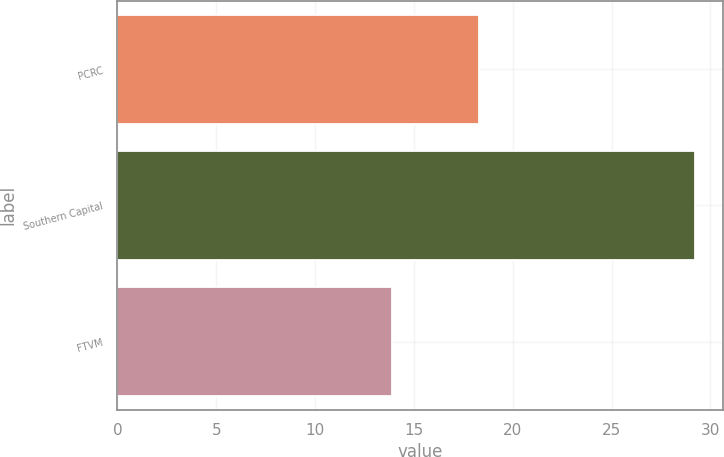<chart> <loc_0><loc_0><loc_500><loc_500><bar_chart><fcel>PCRC<fcel>Southern Capital<fcel>FTVM<nl><fcel>18.3<fcel>29.2<fcel>13.9<nl></chart> 